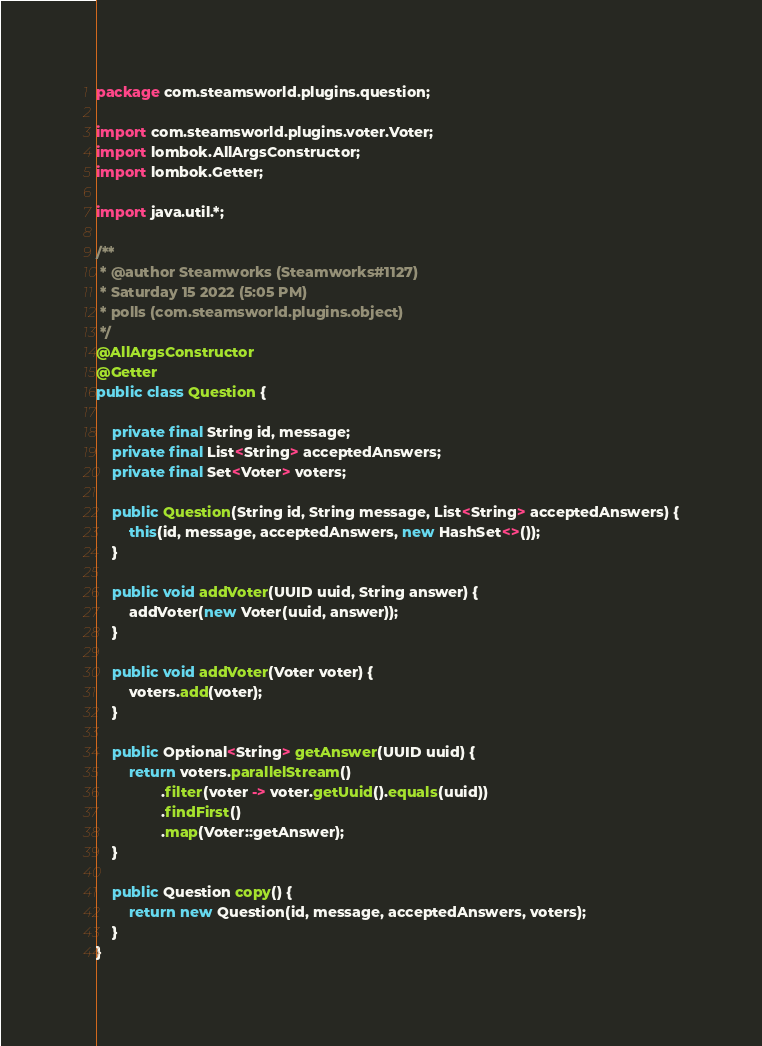<code> <loc_0><loc_0><loc_500><loc_500><_Java_>package com.steamsworld.plugins.question;

import com.steamsworld.plugins.voter.Voter;
import lombok.AllArgsConstructor;
import lombok.Getter;

import java.util.*;

/**
 * @author Steamworks (Steamworks#1127)
 * Saturday 15 2022 (5:05 PM)
 * polls (com.steamsworld.plugins.object)
 */
@AllArgsConstructor
@Getter
public class Question {

    private final String id, message;
    private final List<String> acceptedAnswers;
    private final Set<Voter> voters;

    public Question(String id, String message, List<String> acceptedAnswers) {
        this(id, message, acceptedAnswers, new HashSet<>());
    }

    public void addVoter(UUID uuid, String answer) {
        addVoter(new Voter(uuid, answer));
    }

    public void addVoter(Voter voter) {
        voters.add(voter);
    }

    public Optional<String> getAnswer(UUID uuid) {
        return voters.parallelStream()
                .filter(voter -> voter.getUuid().equals(uuid))
                .findFirst()
                .map(Voter::getAnswer);
    }

    public Question copy() {
        return new Question(id, message, acceptedAnswers, voters);
    }
}
</code> 